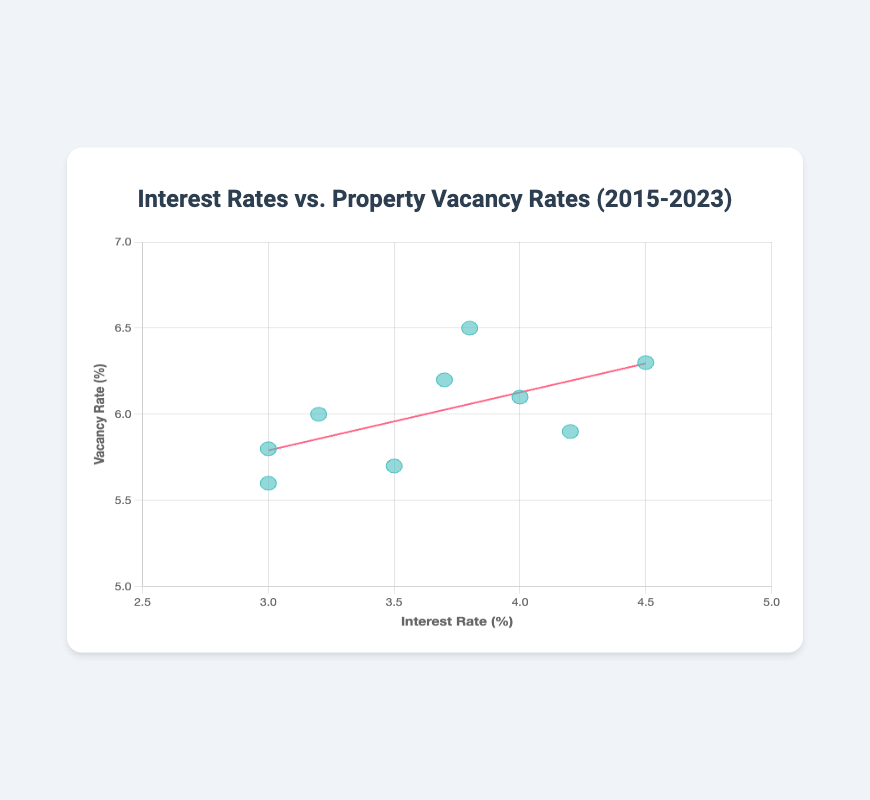What is the title of the plot? The title is located at the top of the chart and serves as a brief description of what the plotted data represents.
Answer: Interest Rates vs. Property Vacancy Rates (2015-2023) What are the labels of the x-axis and y-axis? The labels indicate what the data points on each axis represent. The x-axis label is at the bottom, and the y-axis label is on the left side.
Answer: x-axis: Interest Rate (%), y-axis: Vacancy Rate (%) How many data points are represented in the scatter plot? Each data point corresponds to one entry in the dataset and is represented by a circle on the plot. Count the number of circles to find the total.
Answer: 9 What color are the data points in the scatter plot? The data points are colored to distinguish them from other elements. The description specifies a teal-like color.
Answer: Teal What year has the highest vacancy rate and what is that rate? Identify the data point with the highest y-coordinate and refer to the tooltip or data to find the corresponding year and rate.
Answer: 2020, 6.5% What is the general trend shown by the trendline in the plot? Observe the trendline's slope to determine whether it indicates an increasing or decreasing relationship between the interest rate and vacancy rate.
Answer: Increasing Which year has the lowest interest rate and corresponding vacancy rate? Identify the data point with the lowest x-coordinate and refer to the tooltip or data to find the corresponding year and rate.
Answer: 2015, 5.6% Calculate the average interest rate over the years 2015 to 2023. Sum all the interest rates and divide by the total number of years (9).
Answer: (3.0 + 3.5 + 4.0 + 4.5 + 4.2 + 3.8 + 3.2 + 3.0 + 3.7) / 9 = 3.66 Is there a year with a vacancy rate equal to 6%? If so, which year(s)? Look at the y-coordinate values and check if any of them are equal to 6.0. Refer to the tooltip or data for the year(s).
Answer: 2021 Is there any data point where both the interest rate and vacancy rate are lower compared to all other years? Compare each data point to see if it has the lowest values for both the x- and y-axes.
Answer: No 